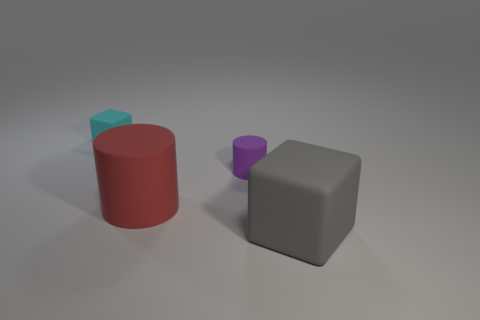Add 2 big red rubber cylinders. How many objects exist? 6 Subtract all gray things. Subtract all purple cylinders. How many objects are left? 2 Add 3 big gray objects. How many big gray objects are left? 4 Add 4 purple cylinders. How many purple cylinders exist? 5 Subtract 1 red cylinders. How many objects are left? 3 